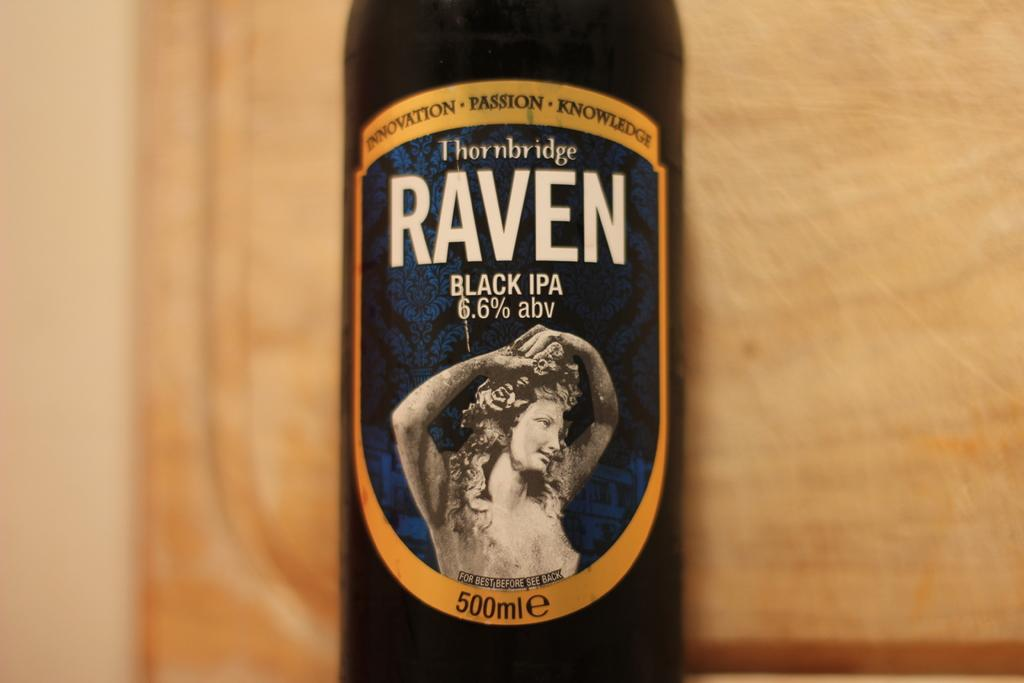<image>
Share a concise interpretation of the image provided. A bottle of Thornbridge Raven Black IPA rests on a wooden plank. 